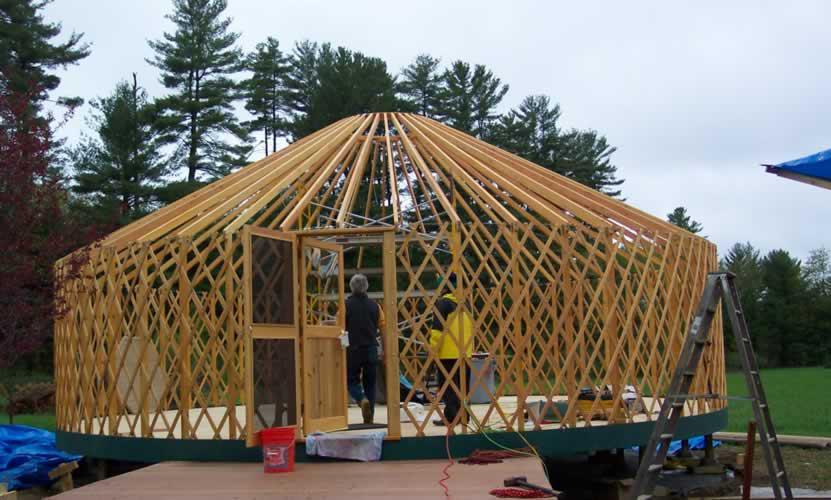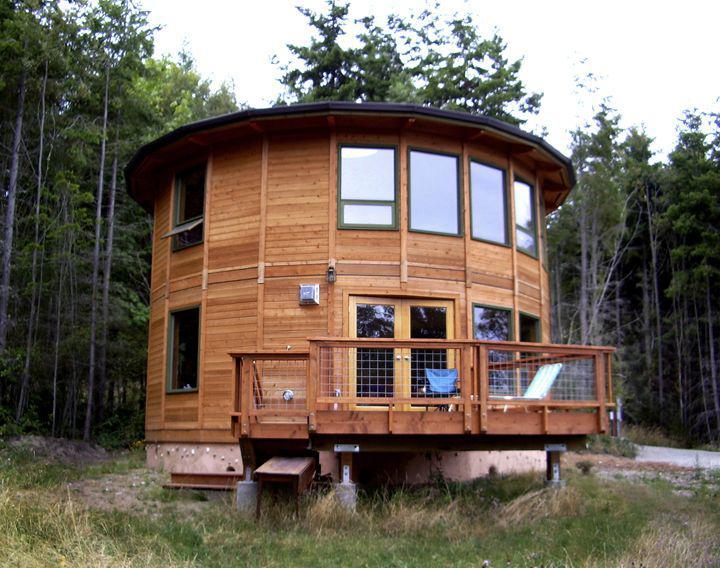The first image is the image on the left, the second image is the image on the right. Given the left and right images, does the statement "In one image, a round wooden house is under construction with an incomplete roof." hold true? Answer yes or no. Yes. 